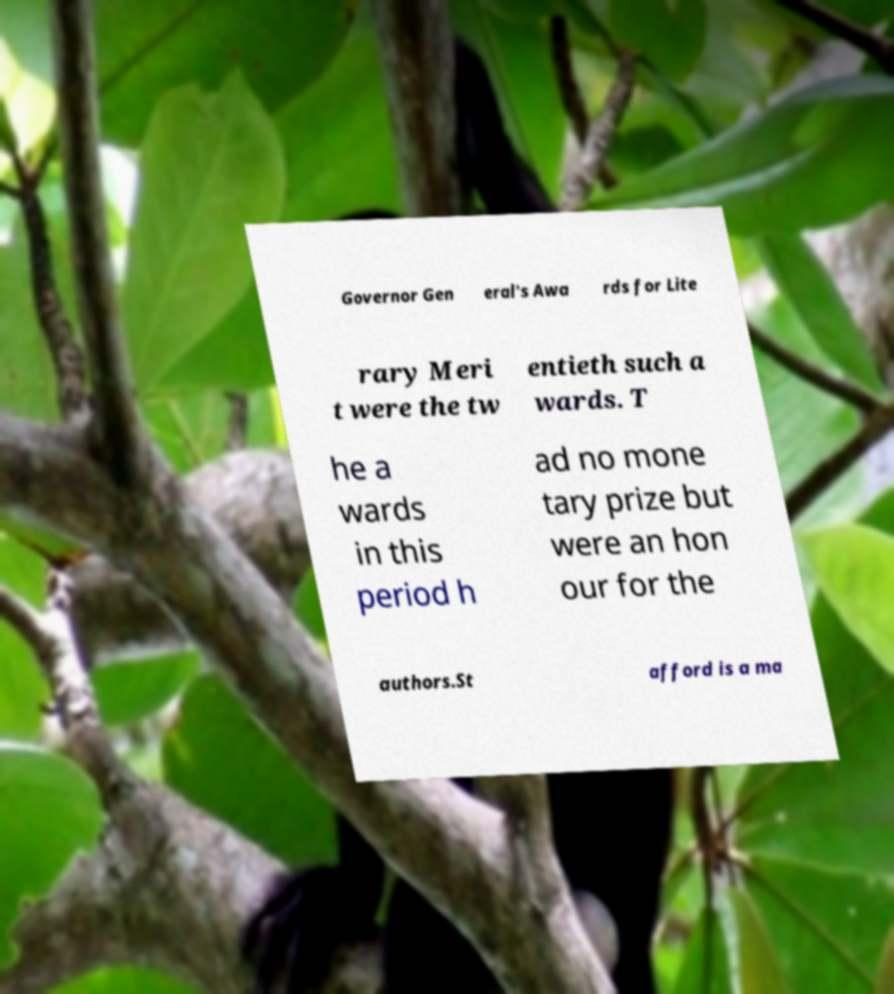Could you extract and type out the text from this image? Governor Gen eral's Awa rds for Lite rary Meri t were the tw entieth such a wards. T he a wards in this period h ad no mone tary prize but were an hon our for the authors.St afford is a ma 